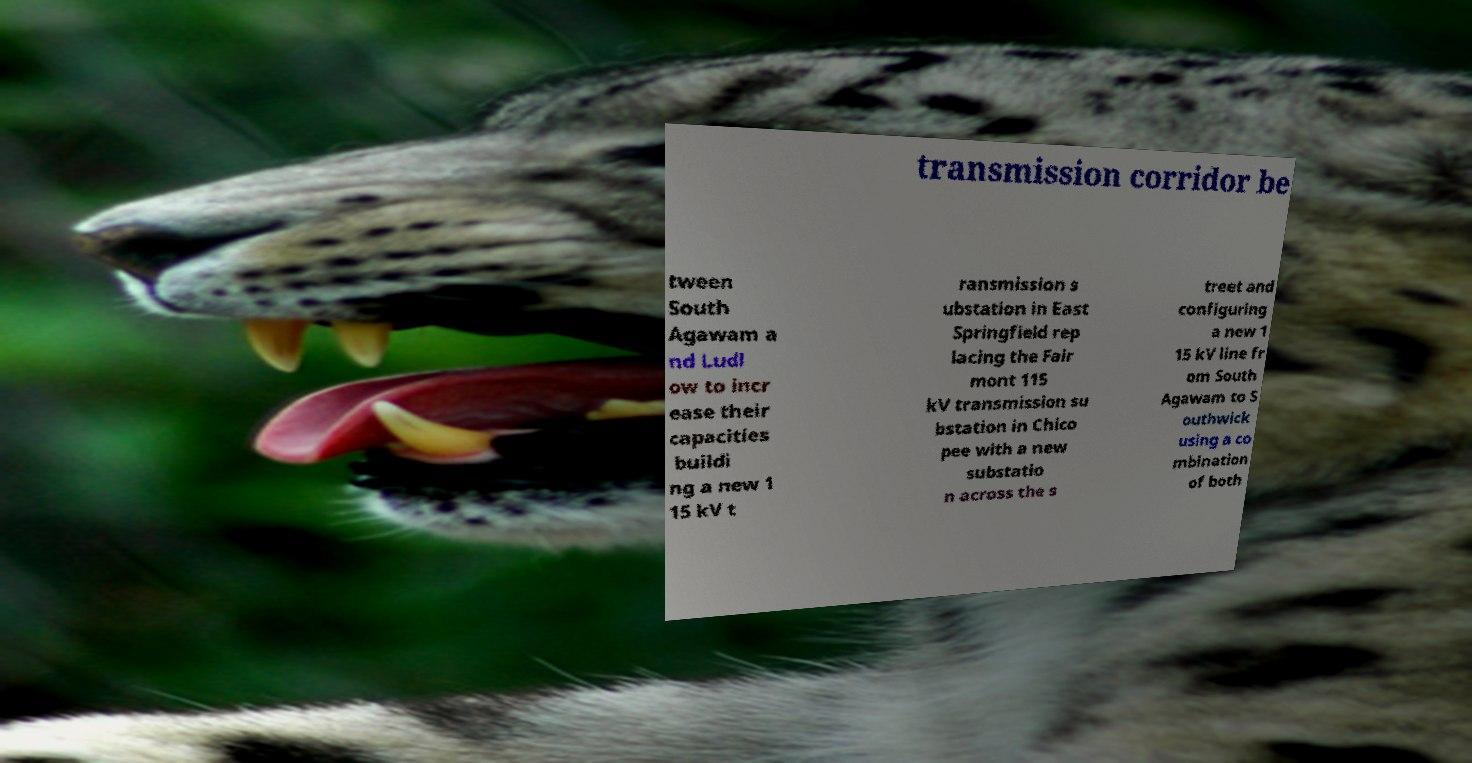I need the written content from this picture converted into text. Can you do that? transmission corridor be tween South Agawam a nd Ludl ow to incr ease their capacities buildi ng a new 1 15 kV t ransmission s ubstation in East Springfield rep lacing the Fair mont 115 kV transmission su bstation in Chico pee with a new substatio n across the s treet and configuring a new 1 15 kV line fr om South Agawam to S outhwick using a co mbination of both 